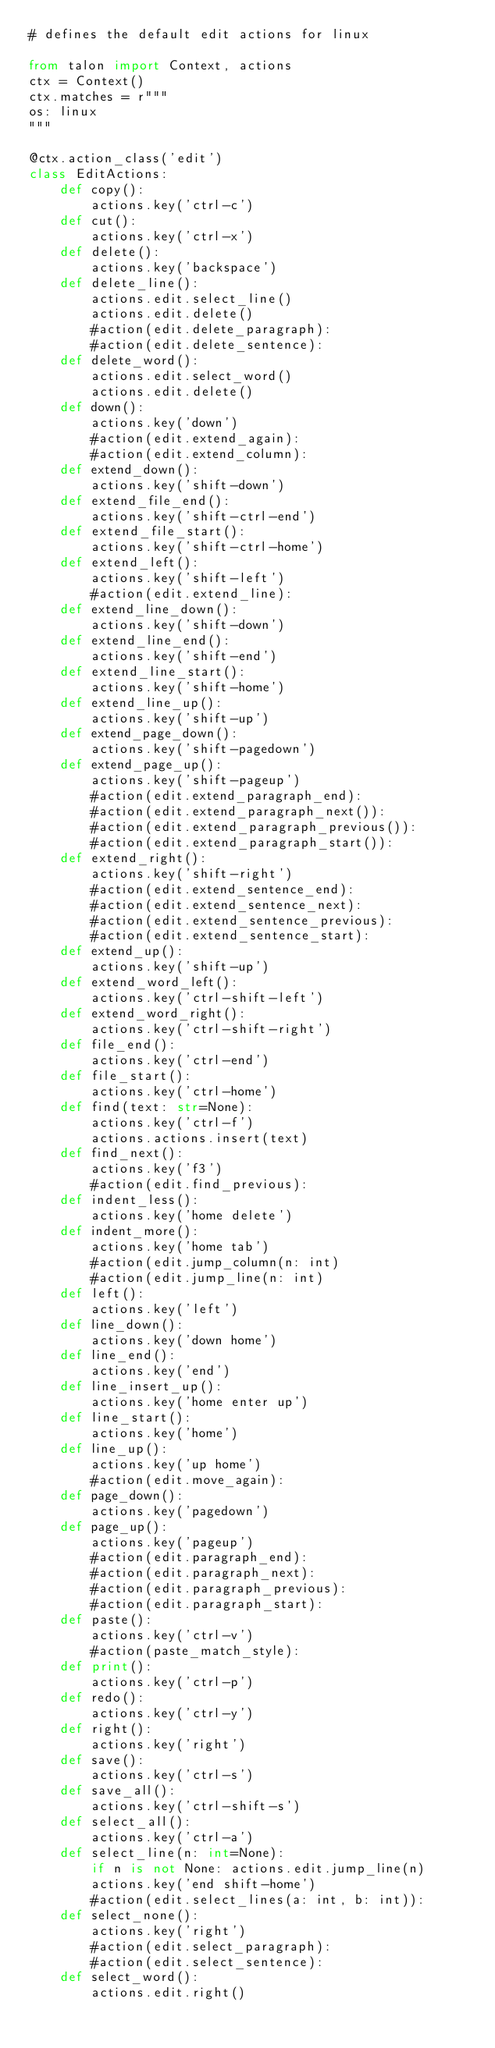<code> <loc_0><loc_0><loc_500><loc_500><_Python_># defines the default edit actions for linux

from talon import Context, actions
ctx = Context()
ctx.matches = r"""
os: linux
"""

@ctx.action_class('edit')
class EditActions:
    def copy():
        actions.key('ctrl-c')
    def cut():
        actions.key('ctrl-x')
    def delete():
        actions.key('backspace')
    def delete_line():
        actions.edit.select_line()
        actions.edit.delete()
        #action(edit.delete_paragraph):
        #action(edit.delete_sentence):
    def delete_word():
        actions.edit.select_word()
        actions.edit.delete()
    def down():
        actions.key('down')
        #action(edit.extend_again):
        #action(edit.extend_column):
    def extend_down():
        actions.key('shift-down')
    def extend_file_end():
        actions.key('shift-ctrl-end')
    def extend_file_start():
        actions.key('shift-ctrl-home')
    def extend_left():
        actions.key('shift-left')
        #action(edit.extend_line):
    def extend_line_down():
        actions.key('shift-down')
    def extend_line_end():
        actions.key('shift-end')
    def extend_line_start():
        actions.key('shift-home')
    def extend_line_up():
        actions.key('shift-up')
    def extend_page_down():
        actions.key('shift-pagedown')
    def extend_page_up():
        actions.key('shift-pageup')
        #action(edit.extend_paragraph_end):
        #action(edit.extend_paragraph_next()):
        #action(edit.extend_paragraph_previous()):
        #action(edit.extend_paragraph_start()):
    def extend_right():
        actions.key('shift-right')
        #action(edit.extend_sentence_end):
        #action(edit.extend_sentence_next):
        #action(edit.extend_sentence_previous):
        #action(edit.extend_sentence_start):
    def extend_up():
        actions.key('shift-up')
    def extend_word_left():
        actions.key('ctrl-shift-left')
    def extend_word_right():
        actions.key('ctrl-shift-right')
    def file_end():
        actions.key('ctrl-end')
    def file_start():
        actions.key('ctrl-home')
    def find(text: str=None):
        actions.key('ctrl-f')
        actions.actions.insert(text)
    def find_next():
        actions.key('f3')
        #action(edit.find_previous):
    def indent_less():
        actions.key('home delete')
    def indent_more():
        actions.key('home tab')
        #action(edit.jump_column(n: int)
        #action(edit.jump_line(n: int)
    def left():
        actions.key('left')
    def line_down():
        actions.key('down home')
    def line_end():
        actions.key('end')
    def line_insert_up():
        actions.key('home enter up')
    def line_start():
        actions.key('home')
    def line_up():
        actions.key('up home')
        #action(edit.move_again):
    def page_down():
        actions.key('pagedown')
    def page_up():
        actions.key('pageup')
        #action(edit.paragraph_end):
        #action(edit.paragraph_next):
        #action(edit.paragraph_previous):
        #action(edit.paragraph_start):
    def paste():
        actions.key('ctrl-v')
        #action(paste_match_style):
    def print():
        actions.key('ctrl-p')
    def redo():
        actions.key('ctrl-y')
    def right():
        actions.key('right')
    def save():
        actions.key('ctrl-s')
    def save_all():
        actions.key('ctrl-shift-s')
    def select_all():
        actions.key('ctrl-a')
    def select_line(n: int=None):
        if n is not None: actions.edit.jump_line(n)
        actions.key('end shift-home')
        #action(edit.select_lines(a: int, b: int)):
    def select_none():
        actions.key('right')
        #action(edit.select_paragraph):
        #action(edit.select_sentence):
    def select_word():
        actions.edit.right()</code> 